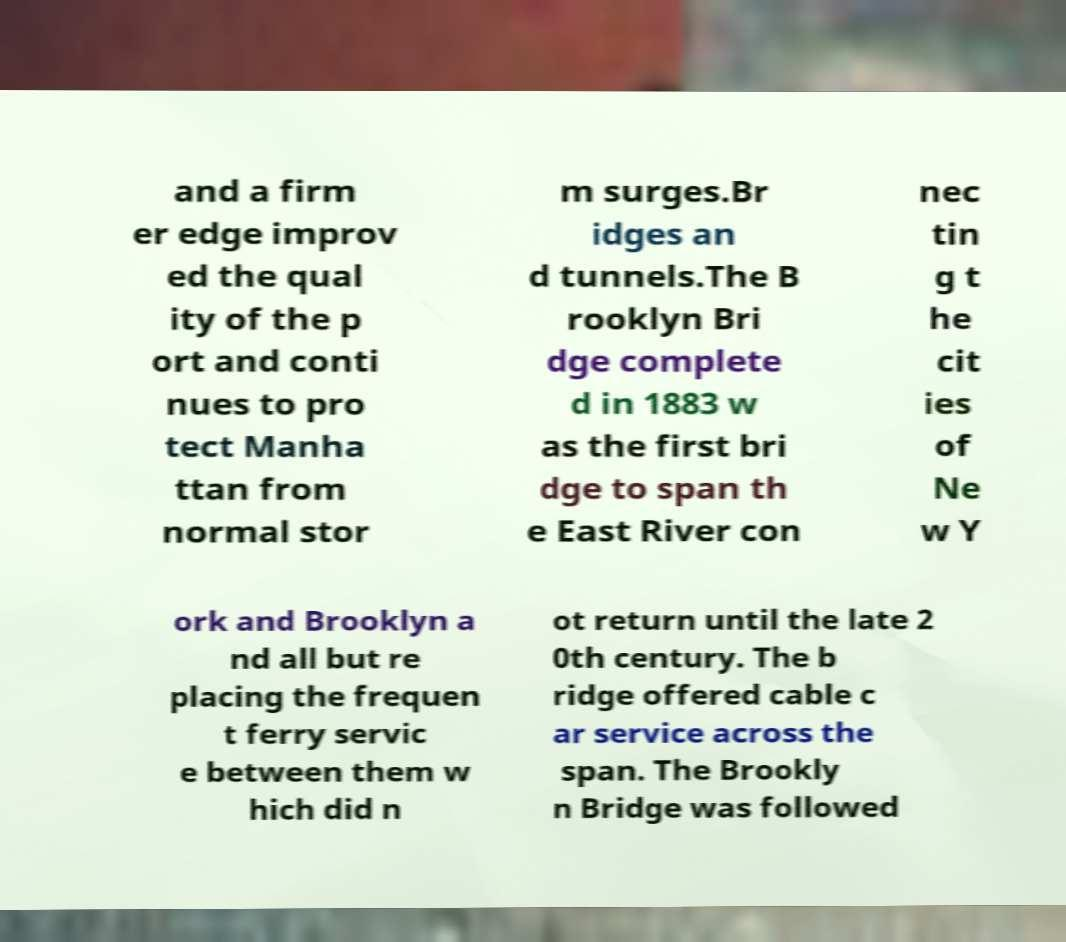For documentation purposes, I need the text within this image transcribed. Could you provide that? and a firm er edge improv ed the qual ity of the p ort and conti nues to pro tect Manha ttan from normal stor m surges.Br idges an d tunnels.The B rooklyn Bri dge complete d in 1883 w as the first bri dge to span th e East River con nec tin g t he cit ies of Ne w Y ork and Brooklyn a nd all but re placing the frequen t ferry servic e between them w hich did n ot return until the late 2 0th century. The b ridge offered cable c ar service across the span. The Brookly n Bridge was followed 